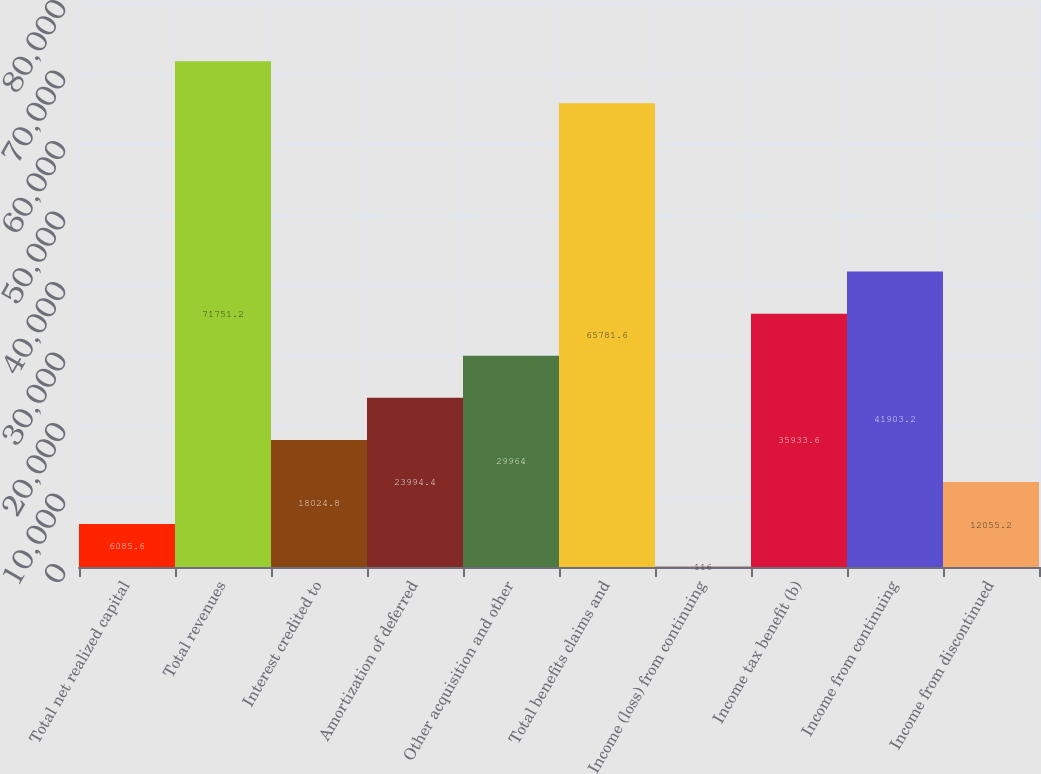Convert chart. <chart><loc_0><loc_0><loc_500><loc_500><bar_chart><fcel>Total net realized capital<fcel>Total revenues<fcel>Interest credited to<fcel>Amortization of deferred<fcel>Other acquisition and other<fcel>Total benefits claims and<fcel>Income (loss) from continuing<fcel>Income tax benefit (b)<fcel>Income from continuing<fcel>Income from discontinued<nl><fcel>6085.6<fcel>71751.2<fcel>18024.8<fcel>23994.4<fcel>29964<fcel>65781.6<fcel>116<fcel>35933.6<fcel>41903.2<fcel>12055.2<nl></chart> 